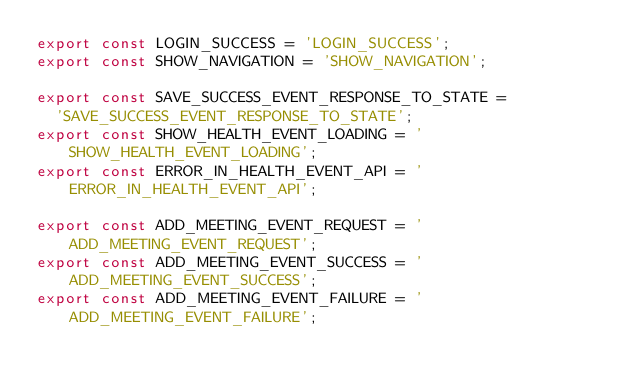<code> <loc_0><loc_0><loc_500><loc_500><_JavaScript_>export const LOGIN_SUCCESS = 'LOGIN_SUCCESS';
export const SHOW_NAVIGATION = 'SHOW_NAVIGATION';

export const SAVE_SUCCESS_EVENT_RESPONSE_TO_STATE =
  'SAVE_SUCCESS_EVENT_RESPONSE_TO_STATE';
export const SHOW_HEALTH_EVENT_LOADING = 'SHOW_HEALTH_EVENT_LOADING';
export const ERROR_IN_HEALTH_EVENT_API = 'ERROR_IN_HEALTH_EVENT_API';

export const ADD_MEETING_EVENT_REQUEST = 'ADD_MEETING_EVENT_REQUEST';
export const ADD_MEETING_EVENT_SUCCESS = 'ADD_MEETING_EVENT_SUCCESS';
export const ADD_MEETING_EVENT_FAILURE = 'ADD_MEETING_EVENT_FAILURE';
</code> 